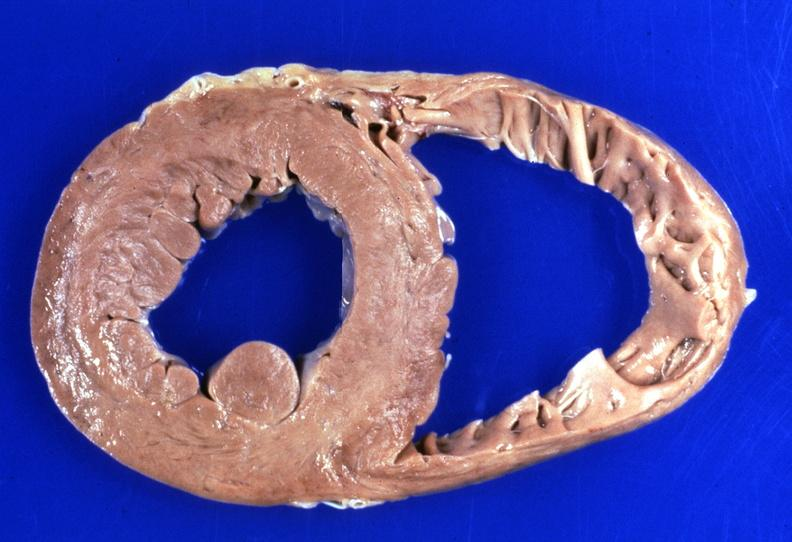does this image show heart, hemochromatosis?
Answer the question using a single word or phrase. Yes 